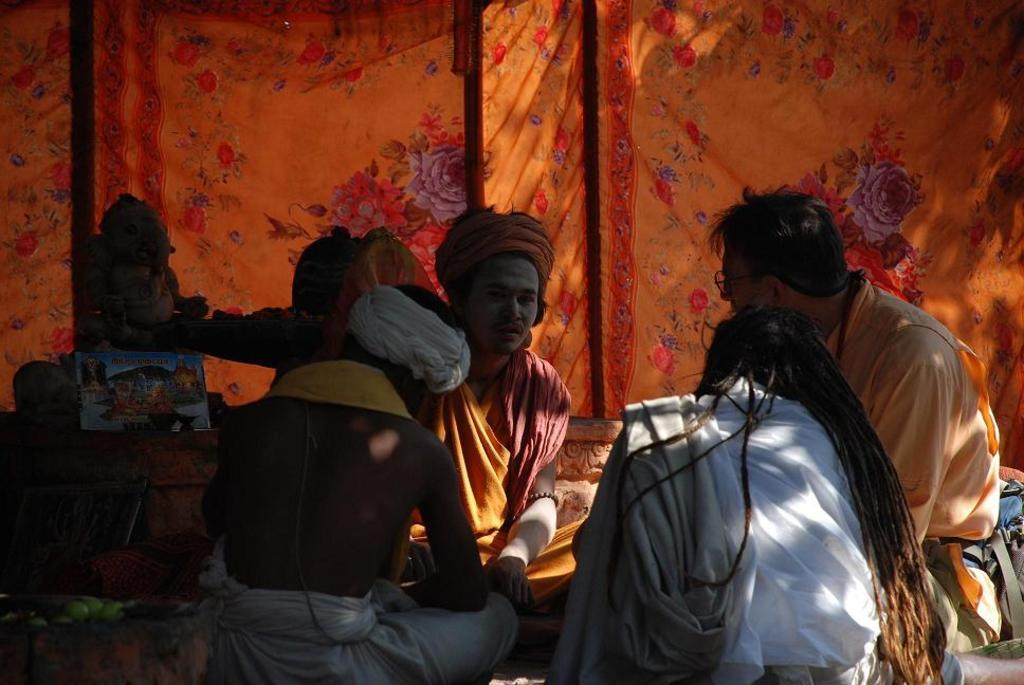What are the people in the image doing? The priests are sitting and discussing something in the image. What can be seen near the priests? There is a small idol visible in the image. What type of curtain is present in the image? There is an orange flower curtain in the image. Can you tell me how many clouds are visible in the image? There are no clouds visible in the image, as it is an indoor setting with a focus on the priests and the idol. What type of parent is present in the image? There is no parent present in the image; it features priests and an idol. 